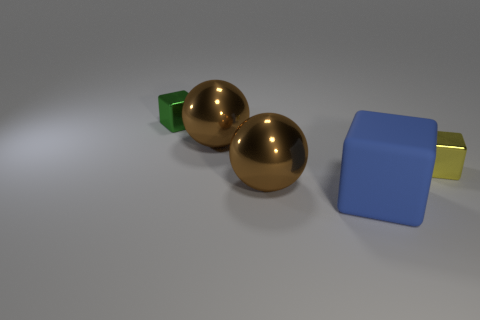Subtract all yellow balls. Subtract all yellow cubes. How many balls are left? 2 Add 1 brown metal cylinders. How many objects exist? 6 Subtract all balls. How many objects are left? 3 Subtract all large gray metal cylinders. Subtract all small shiny blocks. How many objects are left? 3 Add 5 metal balls. How many metal balls are left? 7 Add 3 blue rubber objects. How many blue rubber objects exist? 4 Subtract 1 blue blocks. How many objects are left? 4 